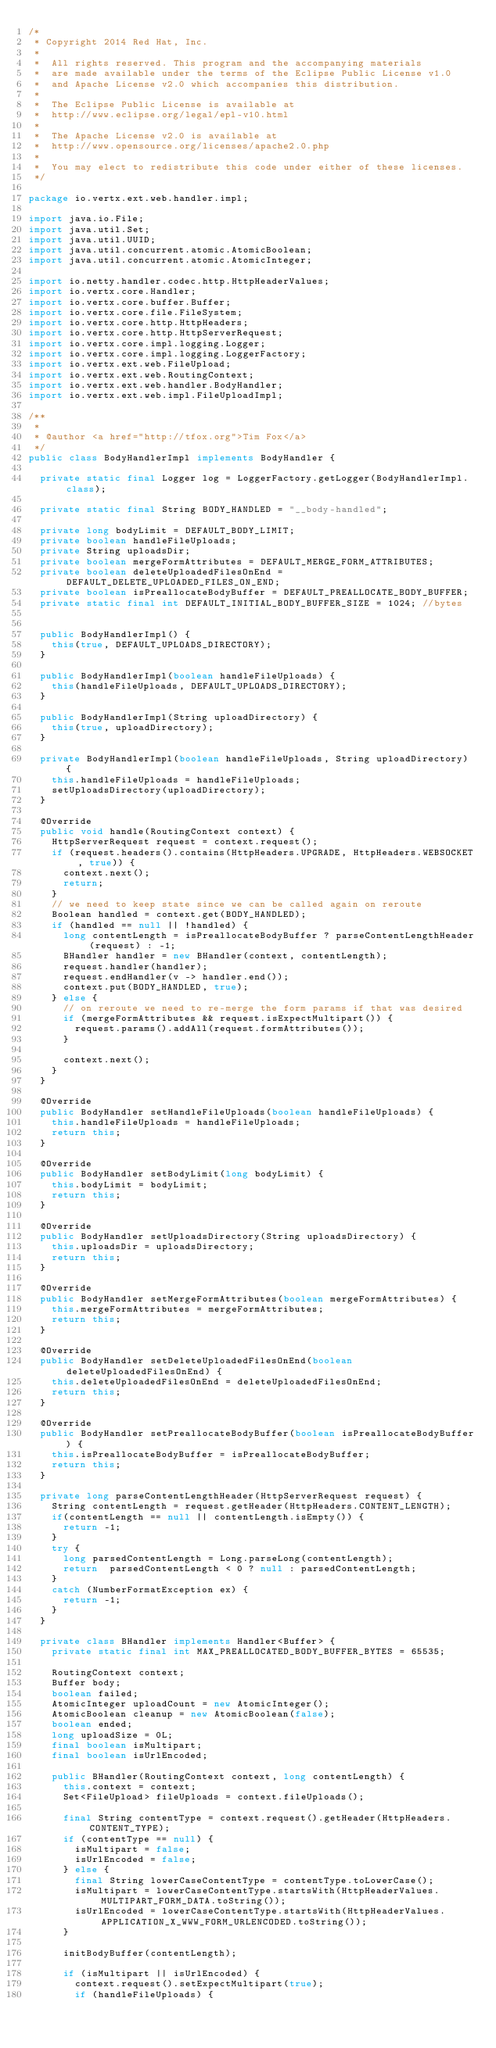Convert code to text. <code><loc_0><loc_0><loc_500><loc_500><_Java_>/*
 * Copyright 2014 Red Hat, Inc.
 *
 *  All rights reserved. This program and the accompanying materials
 *  are made available under the terms of the Eclipse Public License v1.0
 *  and Apache License v2.0 which accompanies this distribution.
 *
 *  The Eclipse Public License is available at
 *  http://www.eclipse.org/legal/epl-v10.html
 *
 *  The Apache License v2.0 is available at
 *  http://www.opensource.org/licenses/apache2.0.php
 *
 *  You may elect to redistribute this code under either of these licenses.
 */

package io.vertx.ext.web.handler.impl;

import java.io.File;
import java.util.Set;
import java.util.UUID;
import java.util.concurrent.atomic.AtomicBoolean;
import java.util.concurrent.atomic.AtomicInteger;

import io.netty.handler.codec.http.HttpHeaderValues;
import io.vertx.core.Handler;
import io.vertx.core.buffer.Buffer;
import io.vertx.core.file.FileSystem;
import io.vertx.core.http.HttpHeaders;
import io.vertx.core.http.HttpServerRequest;
import io.vertx.core.impl.logging.Logger;
import io.vertx.core.impl.logging.LoggerFactory;
import io.vertx.ext.web.FileUpload;
import io.vertx.ext.web.RoutingContext;
import io.vertx.ext.web.handler.BodyHandler;
import io.vertx.ext.web.impl.FileUploadImpl;

/**
 *
 * @author <a href="http://tfox.org">Tim Fox</a>
 */
public class BodyHandlerImpl implements BodyHandler {

  private static final Logger log = LoggerFactory.getLogger(BodyHandlerImpl.class);

  private static final String BODY_HANDLED = "__body-handled";

  private long bodyLimit = DEFAULT_BODY_LIMIT;
  private boolean handleFileUploads;
  private String uploadsDir;
  private boolean mergeFormAttributes = DEFAULT_MERGE_FORM_ATTRIBUTES;
  private boolean deleteUploadedFilesOnEnd = DEFAULT_DELETE_UPLOADED_FILES_ON_END;
  private boolean isPreallocateBodyBuffer = DEFAULT_PREALLOCATE_BODY_BUFFER;
  private static final int DEFAULT_INITIAL_BODY_BUFFER_SIZE = 1024; //bytes


  public BodyHandlerImpl() {
    this(true, DEFAULT_UPLOADS_DIRECTORY);
  }

  public BodyHandlerImpl(boolean handleFileUploads) {
    this(handleFileUploads, DEFAULT_UPLOADS_DIRECTORY);
  }

  public BodyHandlerImpl(String uploadDirectory) {
    this(true, uploadDirectory);
  }

  private BodyHandlerImpl(boolean handleFileUploads, String uploadDirectory) {
    this.handleFileUploads = handleFileUploads;
    setUploadsDirectory(uploadDirectory);
  }

  @Override
  public void handle(RoutingContext context) {
    HttpServerRequest request = context.request();
    if (request.headers().contains(HttpHeaders.UPGRADE, HttpHeaders.WEBSOCKET, true)) {
      context.next();
      return;
    }
    // we need to keep state since we can be called again on reroute
    Boolean handled = context.get(BODY_HANDLED);
    if (handled == null || !handled) {
      long contentLength = isPreallocateBodyBuffer ? parseContentLengthHeader(request) : -1;
      BHandler handler = new BHandler(context, contentLength);
      request.handler(handler);
      request.endHandler(v -> handler.end());
      context.put(BODY_HANDLED, true);
    } else {
      // on reroute we need to re-merge the form params if that was desired
      if (mergeFormAttributes && request.isExpectMultipart()) {
        request.params().addAll(request.formAttributes());
      }

      context.next();
    }
  }

  @Override
  public BodyHandler setHandleFileUploads(boolean handleFileUploads) {
    this.handleFileUploads = handleFileUploads;
    return this;
  }

  @Override
  public BodyHandler setBodyLimit(long bodyLimit) {
    this.bodyLimit = bodyLimit;
    return this;
  }

  @Override
  public BodyHandler setUploadsDirectory(String uploadsDirectory) {
    this.uploadsDir = uploadsDirectory;
    return this;
  }

  @Override
  public BodyHandler setMergeFormAttributes(boolean mergeFormAttributes) {
    this.mergeFormAttributes = mergeFormAttributes;
    return this;
  }

  @Override
  public BodyHandler setDeleteUploadedFilesOnEnd(boolean deleteUploadedFilesOnEnd) {
    this.deleteUploadedFilesOnEnd = deleteUploadedFilesOnEnd;
    return this;
  }

  @Override
  public BodyHandler setPreallocateBodyBuffer(boolean isPreallocateBodyBuffer) {
    this.isPreallocateBodyBuffer = isPreallocateBodyBuffer;
    return this;
  }

  private long parseContentLengthHeader(HttpServerRequest request) {
    String contentLength = request.getHeader(HttpHeaders.CONTENT_LENGTH);
    if(contentLength == null || contentLength.isEmpty()) {
      return -1;
    }
    try {
      long parsedContentLength = Long.parseLong(contentLength);
      return  parsedContentLength < 0 ? null : parsedContentLength;
    }
    catch (NumberFormatException ex) {
      return -1;
    }
  }

  private class BHandler implements Handler<Buffer> {
    private static final int MAX_PREALLOCATED_BODY_BUFFER_BYTES = 65535;

    RoutingContext context;
    Buffer body;
    boolean failed;
    AtomicInteger uploadCount = new AtomicInteger();
    AtomicBoolean cleanup = new AtomicBoolean(false);
    boolean ended;
    long uploadSize = 0L;
    final boolean isMultipart;
    final boolean isUrlEncoded;

    public BHandler(RoutingContext context, long contentLength) {
      this.context = context;
      Set<FileUpload> fileUploads = context.fileUploads();

      final String contentType = context.request().getHeader(HttpHeaders.CONTENT_TYPE);
      if (contentType == null) {
        isMultipart = false;
        isUrlEncoded = false;
      } else {
        final String lowerCaseContentType = contentType.toLowerCase();
        isMultipart = lowerCaseContentType.startsWith(HttpHeaderValues.MULTIPART_FORM_DATA.toString());
        isUrlEncoded = lowerCaseContentType.startsWith(HttpHeaderValues.APPLICATION_X_WWW_FORM_URLENCODED.toString());
      }

      initBodyBuffer(contentLength);

      if (isMultipart || isUrlEncoded) {
        context.request().setExpectMultipart(true);
        if (handleFileUploads) {</code> 